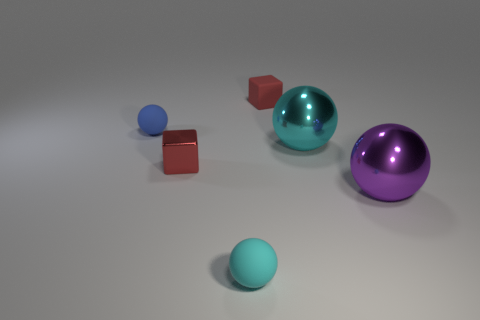There is a matte block; is it the same color as the rubber object that is in front of the purple ball?
Offer a very short reply. No. Are there fewer cyan metallic spheres to the left of the small cyan rubber sphere than tiny matte blocks that are in front of the blue rubber object?
Provide a short and direct response. No. There is a tiny thing that is both to the right of the shiny block and behind the purple metal ball; what color is it?
Offer a terse response. Red. There is a purple thing; is it the same size as the rubber sphere that is in front of the blue sphere?
Your answer should be compact. No. There is a small matte thing in front of the large purple metal ball; what shape is it?
Provide a succinct answer. Sphere. Are there any other things that have the same material as the large purple sphere?
Keep it short and to the point. Yes. Is the number of small red objects behind the red rubber cube greater than the number of tiny gray metal things?
Ensure brevity in your answer.  No. How many large metallic balls are behind the cyan object in front of the cyan ball that is behind the small cyan ball?
Ensure brevity in your answer.  2. Do the thing that is in front of the purple object and the cube that is behind the small red metallic thing have the same size?
Give a very brief answer. Yes. There is a tiny block that is behind the rubber sphere that is behind the tiny red metal cube; what is its material?
Your answer should be very brief. Rubber. 